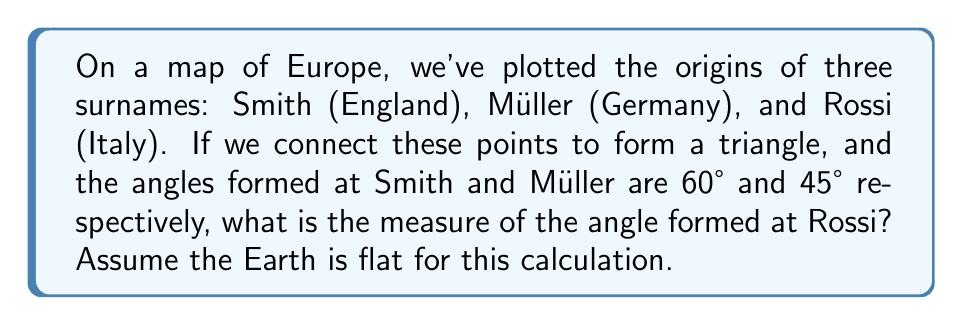Show me your answer to this math problem. Let's approach this step-by-step:

1) In any triangle, the sum of all interior angles is always 180°. This is a fundamental property of triangles.

2) We can express this as an equation:
   $$ \angle Smith + \angle Müller + \angle Rossi = 180° $$

3) We're given that:
   $$ \angle Smith = 60° $$
   $$ \angle Müller = 45° $$

4) Let's substitute these known values into our equation:
   $$ 60° + 45° + \angle Rossi = 180° $$

5) Now we can solve for $\angle Rossi$:
   $$ \angle Rossi = 180° - (60° + 45°) $$
   $$ \angle Rossi = 180° - 105° $$
   $$ \angle Rossi = 75° $$

Therefore, the angle formed at the point representing the origin of the Rossi surname is 75°.

[asy]
unitsize(1cm);
pair A = (0,0), B = (4,0), C = (2,3.46);
draw(A--B--C--A);
label("Smith", A, SW);
label("Müller", B, SE);
label("Rossi", C, N);
label("60°", A, NE);
label("45°", B, NW);
label("75°", C, S);
[/asy]
Answer: 75° 